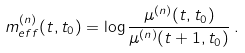Convert formula to latex. <formula><loc_0><loc_0><loc_500><loc_500>m _ { e f f } ^ { ( n ) } ( t , t _ { 0 } ) = \log \frac { \mu ^ { ( n ) } ( t , t _ { 0 } ) } { \mu ^ { ( n ) } ( t + 1 , t _ { 0 } ) } \, .</formula> 